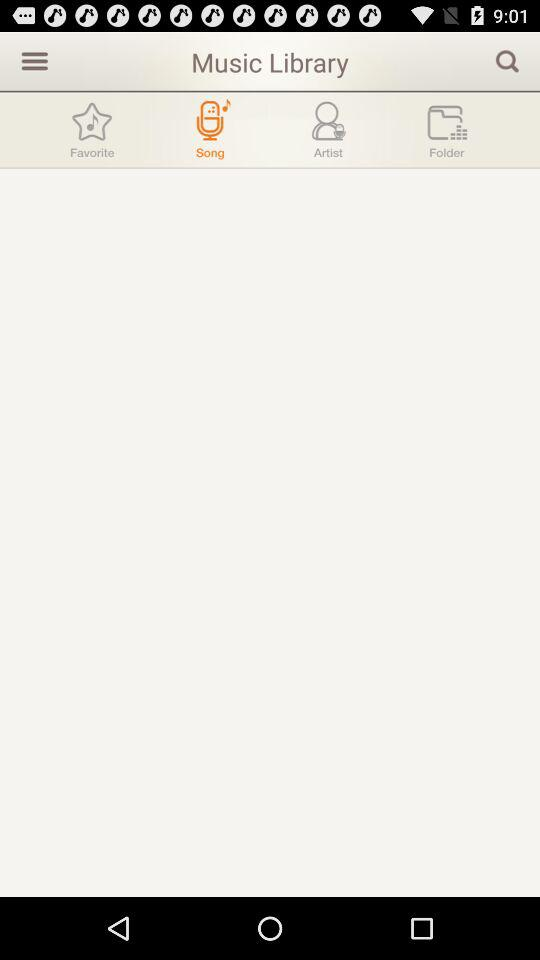Which tab is selected? The selected tab is "Tab". 